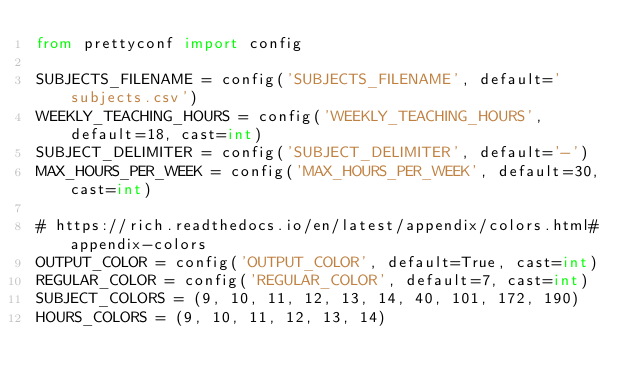<code> <loc_0><loc_0><loc_500><loc_500><_Python_>from prettyconf import config

SUBJECTS_FILENAME = config('SUBJECTS_FILENAME', default='subjects.csv')
WEEKLY_TEACHING_HOURS = config('WEEKLY_TEACHING_HOURS', default=18, cast=int)
SUBJECT_DELIMITER = config('SUBJECT_DELIMITER', default='-')
MAX_HOURS_PER_WEEK = config('MAX_HOURS_PER_WEEK', default=30, cast=int)

# https://rich.readthedocs.io/en/latest/appendix/colors.html#appendix-colors
OUTPUT_COLOR = config('OUTPUT_COLOR', default=True, cast=int)
REGULAR_COLOR = config('REGULAR_COLOR', default=7, cast=int)
SUBJECT_COLORS = (9, 10, 11, 12, 13, 14, 40, 101, 172, 190)
HOURS_COLORS = (9, 10, 11, 12, 13, 14)
</code> 